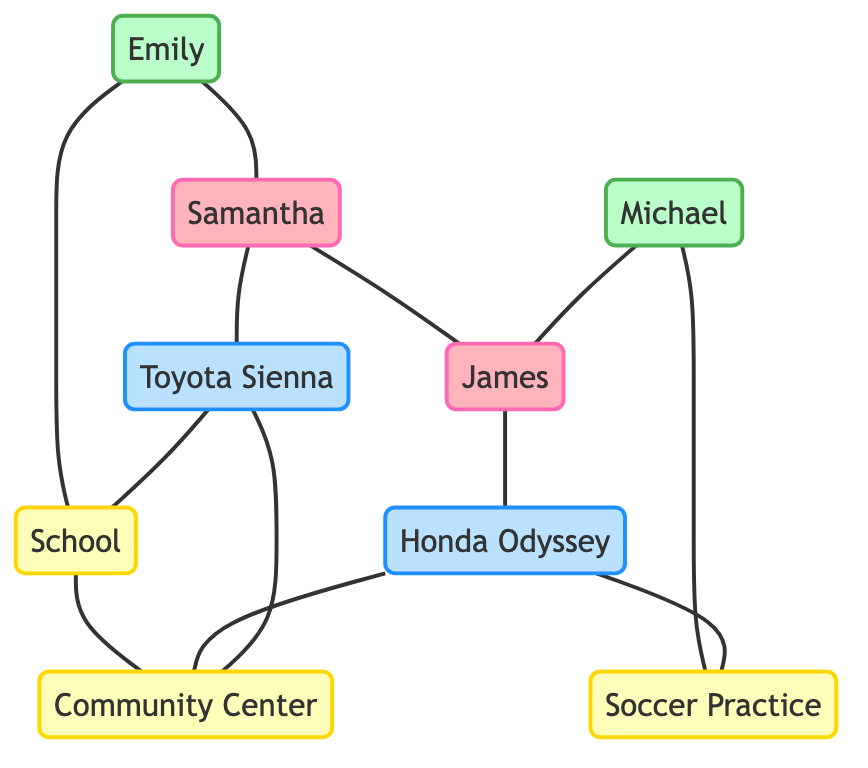What's the total number of nodes in the diagram? The diagram includes a list of nodes: Samantha, James, Emily, Michael, Toyota Sienna, Honda Odyssey, School, Soccer Practice, and Community Center. Counting these gives us 9 nodes.
Answer: 9 Which vehicles are connected to the Community Center? The diagram shows two edges connecting vehicles to the Community Center: Toyota Sienna and Honda Odyssey. Thus, both vehicles are connected to this destination.
Answer: Toyota Sienna, Honda Odyssey Who drives the Toyota Sienna? In the edges, it is indicated that Samantha is connected to and thus drives the Toyota Sienna.
Answer: Samantha How many parents are in the carpool network? The nodes indicate there are two parents: Samantha and James. Therefore, the total count of parents is 2.
Answer: 2 Which destination is reached by the Honda Odyssey? An edge connects the Honda Odyssey to Soccer Practice, indicating that this vehicle reaches that destination.
Answer: Soccer Practice What is the relationship between Emily and Samantha? The diagram shows an edge connecting Emily to Samantha, indicating that Emily is a child and Samantha is her parent.
Answer: Parent-Child What is the shortest path from school to the Community Center? The diagram shows that the path from School to Community Center is direct, meaning they are connected by a single edge.
Answer: School -> Community Center Which child is associated with soccer practice? The diagram shows that Michael is connected to the Soccer Practice, indicating he is the child associated with that activity.
Answer: Michael Are Samantha and James friends? The edges in the diagram directly connect Samantha and James, indicating they share a relationship, which can be inferred as friendship.
Answer: Yes 